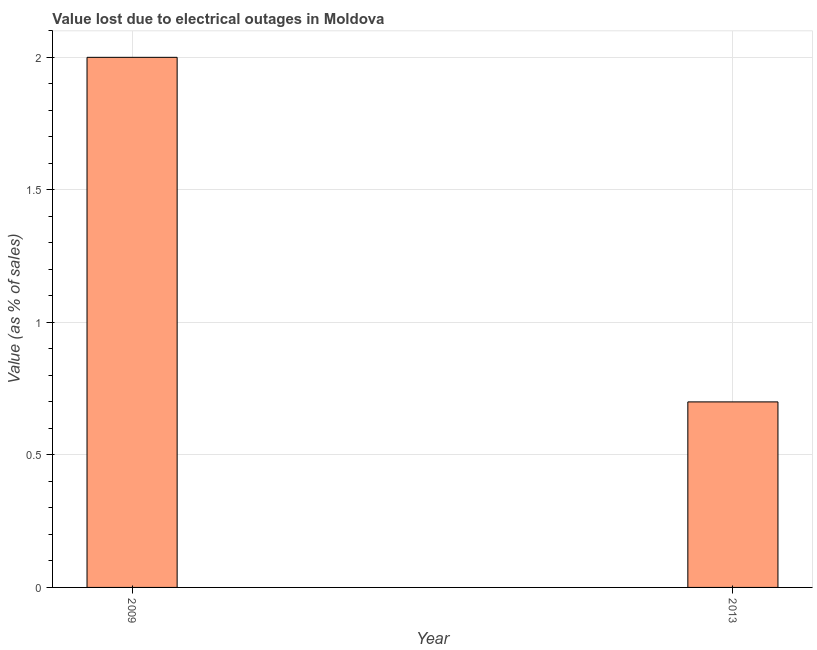What is the title of the graph?
Give a very brief answer. Value lost due to electrical outages in Moldova. What is the label or title of the X-axis?
Keep it short and to the point. Year. What is the label or title of the Y-axis?
Offer a terse response. Value (as % of sales). What is the value lost due to electrical outages in 2013?
Your response must be concise. 0.7. Across all years, what is the maximum value lost due to electrical outages?
Your answer should be very brief. 2. Across all years, what is the minimum value lost due to electrical outages?
Make the answer very short. 0.7. In which year was the value lost due to electrical outages maximum?
Offer a very short reply. 2009. What is the sum of the value lost due to electrical outages?
Offer a very short reply. 2.7. What is the difference between the value lost due to electrical outages in 2009 and 2013?
Ensure brevity in your answer.  1.3. What is the average value lost due to electrical outages per year?
Provide a succinct answer. 1.35. What is the median value lost due to electrical outages?
Your answer should be very brief. 1.35. What is the ratio of the value lost due to electrical outages in 2009 to that in 2013?
Your answer should be very brief. 2.86. In how many years, is the value lost due to electrical outages greater than the average value lost due to electrical outages taken over all years?
Offer a terse response. 1. How many bars are there?
Provide a short and direct response. 2. Are all the bars in the graph horizontal?
Make the answer very short. No. How many years are there in the graph?
Offer a very short reply. 2. What is the Value (as % of sales) in 2009?
Offer a terse response. 2. What is the difference between the Value (as % of sales) in 2009 and 2013?
Provide a succinct answer. 1.3. What is the ratio of the Value (as % of sales) in 2009 to that in 2013?
Give a very brief answer. 2.86. 